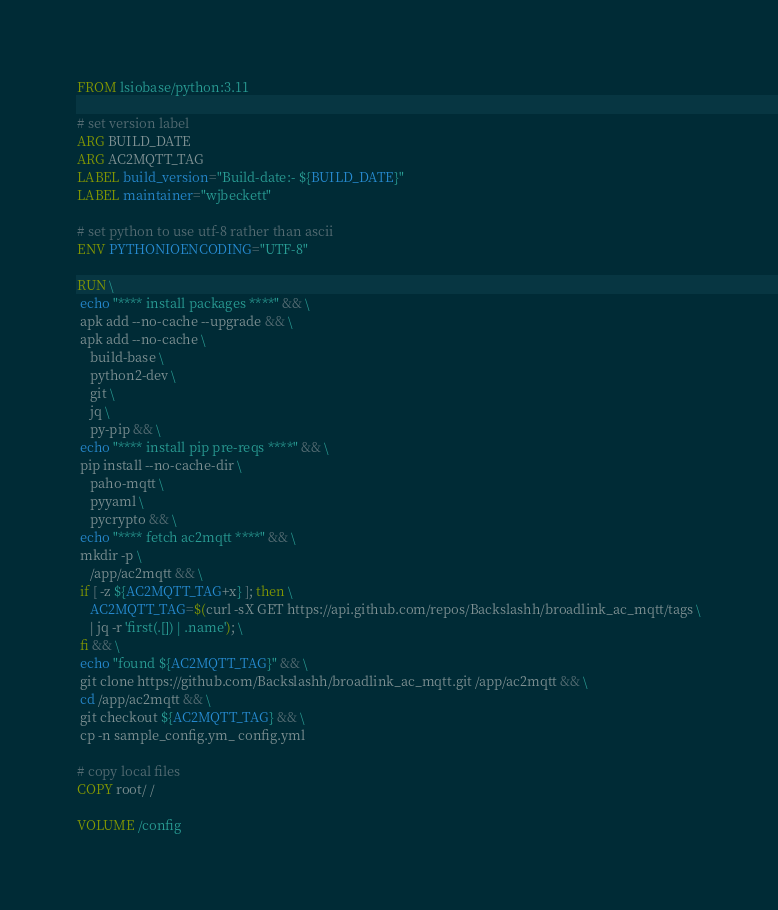Convert code to text. <code><loc_0><loc_0><loc_500><loc_500><_Dockerfile_>FROM lsiobase/python:3.11

# set version label
ARG BUILD_DATE
ARG AC2MQTT_TAG
LABEL build_version="Build-date:- ${BUILD_DATE}"
LABEL maintainer="wjbeckett"

# set python to use utf-8 rather than ascii
ENV PYTHONIOENCODING="UTF-8"

RUN \
 echo "**** install packages ****" && \
 apk add --no-cache --upgrade && \
 apk add --no-cache \
    build-base \
	python2-dev \
	git \
	jq \
	py-pip && \
 echo "**** install pip pre-reqs ****" && \
 pip install --no-cache-dir \
	paho-mqtt \
	pyyaml \
	pycrypto && \
 echo "**** fetch ac2mqtt ****" && \
 mkdir -p \
	/app/ac2mqtt && \
 if [ -z ${AC2MQTT_TAG+x} ]; then \
	AC2MQTT_TAG=$(curl -sX GET https://api.github.com/repos/Backslashh/broadlink_ac_mqtt/tags \
	| jq -r 'first(.[]) | .name'); \
 fi && \
 echo "found ${AC2MQTT_TAG}" && \
 git clone https://github.com/Backslashh/broadlink_ac_mqtt.git /app/ac2mqtt && \
 cd /app/ac2mqtt && \
 git checkout ${AC2MQTT_TAG} && \
 cp -n sample_config.ym_ config.yml

# copy local files
COPY root/ /

VOLUME /config</code> 